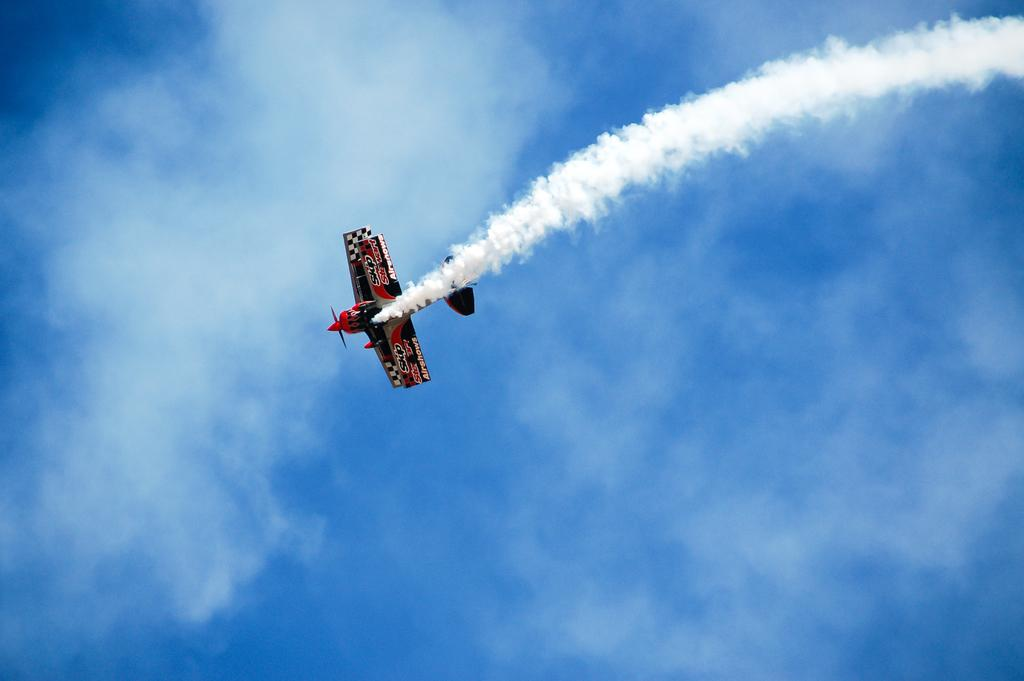What is the main subject in the middle of the image? There is a plane in the middle of the image. What environmental issue can be observed in the image? Air pollution is visible in the image. What can be seen in the sky behind the plane? There are clouds in the sky behind the plane. Where are the crayons and houses located in the image? There are no crayons or houses present in the image. Can you tell me how many basketballs are visible in the image? There are no basketballs visible in the image. 